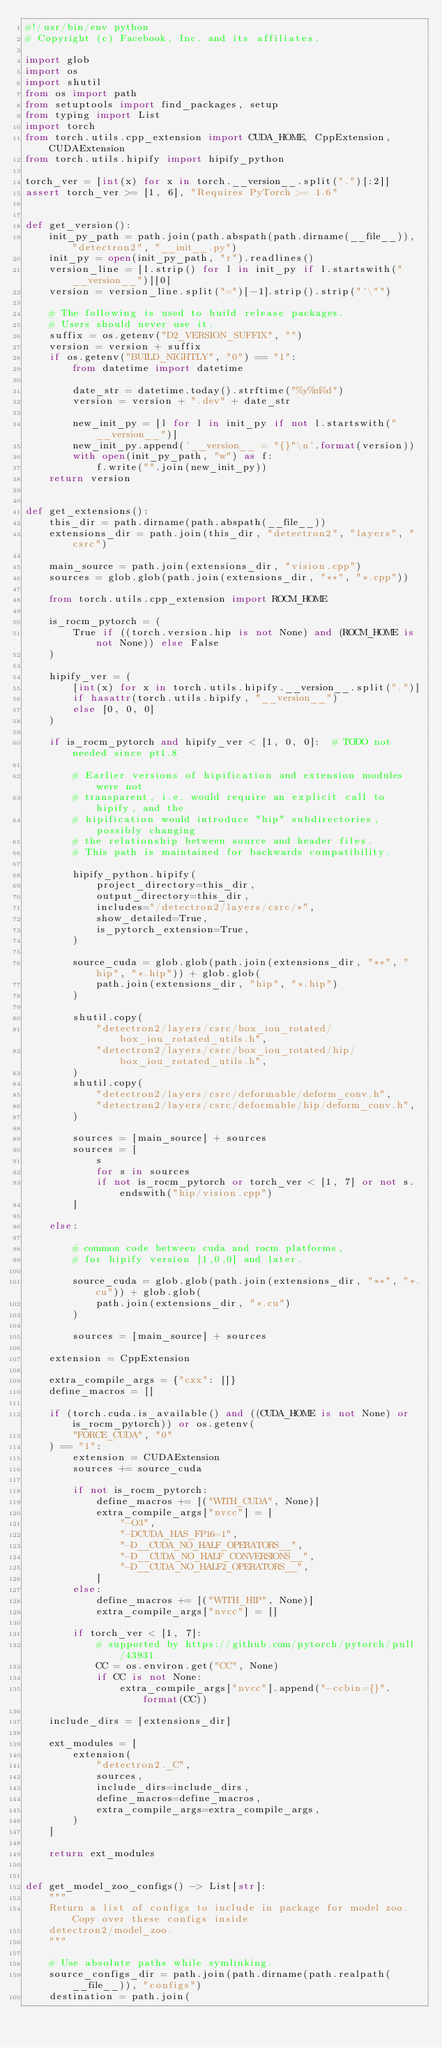<code> <loc_0><loc_0><loc_500><loc_500><_Python_>#!/usr/bin/env python
# Copyright (c) Facebook, Inc. and its affiliates.

import glob
import os
import shutil
from os import path
from setuptools import find_packages, setup
from typing import List
import torch
from torch.utils.cpp_extension import CUDA_HOME, CppExtension, CUDAExtension
from torch.utils.hipify import hipify_python

torch_ver = [int(x) for x in torch.__version__.split(".")[:2]]
assert torch_ver >= [1, 6], "Requires PyTorch >= 1.6"


def get_version():
    init_py_path = path.join(path.abspath(path.dirname(__file__)), "detectron2", "__init__.py")
    init_py = open(init_py_path, "r").readlines()
    version_line = [l.strip() for l in init_py if l.startswith("__version__")][0]
    version = version_line.split("=")[-1].strip().strip("'\"")

    # The following is used to build release packages.
    # Users should never use it.
    suffix = os.getenv("D2_VERSION_SUFFIX", "")
    version = version + suffix
    if os.getenv("BUILD_NIGHTLY", "0") == "1":
        from datetime import datetime

        date_str = datetime.today().strftime("%y%m%d")
        version = version + ".dev" + date_str

        new_init_py = [l for l in init_py if not l.startswith("__version__")]
        new_init_py.append('__version__ = "{}"\n'.format(version))
        with open(init_py_path, "w") as f:
            f.write("".join(new_init_py))
    return version


def get_extensions():
    this_dir = path.dirname(path.abspath(__file__))
    extensions_dir = path.join(this_dir, "detectron2", "layers", "csrc")

    main_source = path.join(extensions_dir, "vision.cpp")
    sources = glob.glob(path.join(extensions_dir, "**", "*.cpp"))

    from torch.utils.cpp_extension import ROCM_HOME

    is_rocm_pytorch = (
        True if ((torch.version.hip is not None) and (ROCM_HOME is not None)) else False
    )

    hipify_ver = (
        [int(x) for x in torch.utils.hipify.__version__.split(".")]
        if hasattr(torch.utils.hipify, "__version__")
        else [0, 0, 0]
    )

    if is_rocm_pytorch and hipify_ver < [1, 0, 0]:  # TODO not needed since pt1.8

        # Earlier versions of hipification and extension modules were not
        # transparent, i.e. would require an explicit call to hipify, and the
        # hipification would introduce "hip" subdirectories, possibly changing
        # the relationship between source and header files.
        # This path is maintained for backwards compatibility.

        hipify_python.hipify(
            project_directory=this_dir,
            output_directory=this_dir,
            includes="/detectron2/layers/csrc/*",
            show_detailed=True,
            is_pytorch_extension=True,
        )

        source_cuda = glob.glob(path.join(extensions_dir, "**", "hip", "*.hip")) + glob.glob(
            path.join(extensions_dir, "hip", "*.hip")
        )

        shutil.copy(
            "detectron2/layers/csrc/box_iou_rotated/box_iou_rotated_utils.h",
            "detectron2/layers/csrc/box_iou_rotated/hip/box_iou_rotated_utils.h",
        )
        shutil.copy(
            "detectron2/layers/csrc/deformable/deform_conv.h",
            "detectron2/layers/csrc/deformable/hip/deform_conv.h",
        )

        sources = [main_source] + sources
        sources = [
            s
            for s in sources
            if not is_rocm_pytorch or torch_ver < [1, 7] or not s.endswith("hip/vision.cpp")
        ]

    else:

        # common code between cuda and rocm platforms,
        # for hipify version [1,0,0] and later.

        source_cuda = glob.glob(path.join(extensions_dir, "**", "*.cu")) + glob.glob(
            path.join(extensions_dir, "*.cu")
        )

        sources = [main_source] + sources

    extension = CppExtension

    extra_compile_args = {"cxx": []}
    define_macros = []

    if (torch.cuda.is_available() and ((CUDA_HOME is not None) or is_rocm_pytorch)) or os.getenv(
        "FORCE_CUDA", "0"
    ) == "1":
        extension = CUDAExtension
        sources += source_cuda

        if not is_rocm_pytorch:
            define_macros += [("WITH_CUDA", None)]
            extra_compile_args["nvcc"] = [
                "-O3",
                "-DCUDA_HAS_FP16=1",
                "-D__CUDA_NO_HALF_OPERATORS__",
                "-D__CUDA_NO_HALF_CONVERSIONS__",
                "-D__CUDA_NO_HALF2_OPERATORS__",
            ]
        else:
            define_macros += [("WITH_HIP", None)]
            extra_compile_args["nvcc"] = []

        if torch_ver < [1, 7]:
            # supported by https://github.com/pytorch/pytorch/pull/43931
            CC = os.environ.get("CC", None)
            if CC is not None:
                extra_compile_args["nvcc"].append("-ccbin={}".format(CC))

    include_dirs = [extensions_dir]

    ext_modules = [
        extension(
            "detectron2._C",
            sources,
            include_dirs=include_dirs,
            define_macros=define_macros,
            extra_compile_args=extra_compile_args,
        )
    ]

    return ext_modules


def get_model_zoo_configs() -> List[str]:
    """
    Return a list of configs to include in package for model zoo. Copy over these configs inside
    detectron2/model_zoo.
    """

    # Use absolute paths while symlinking.
    source_configs_dir = path.join(path.dirname(path.realpath(__file__)), "configs")
    destination = path.join(</code> 